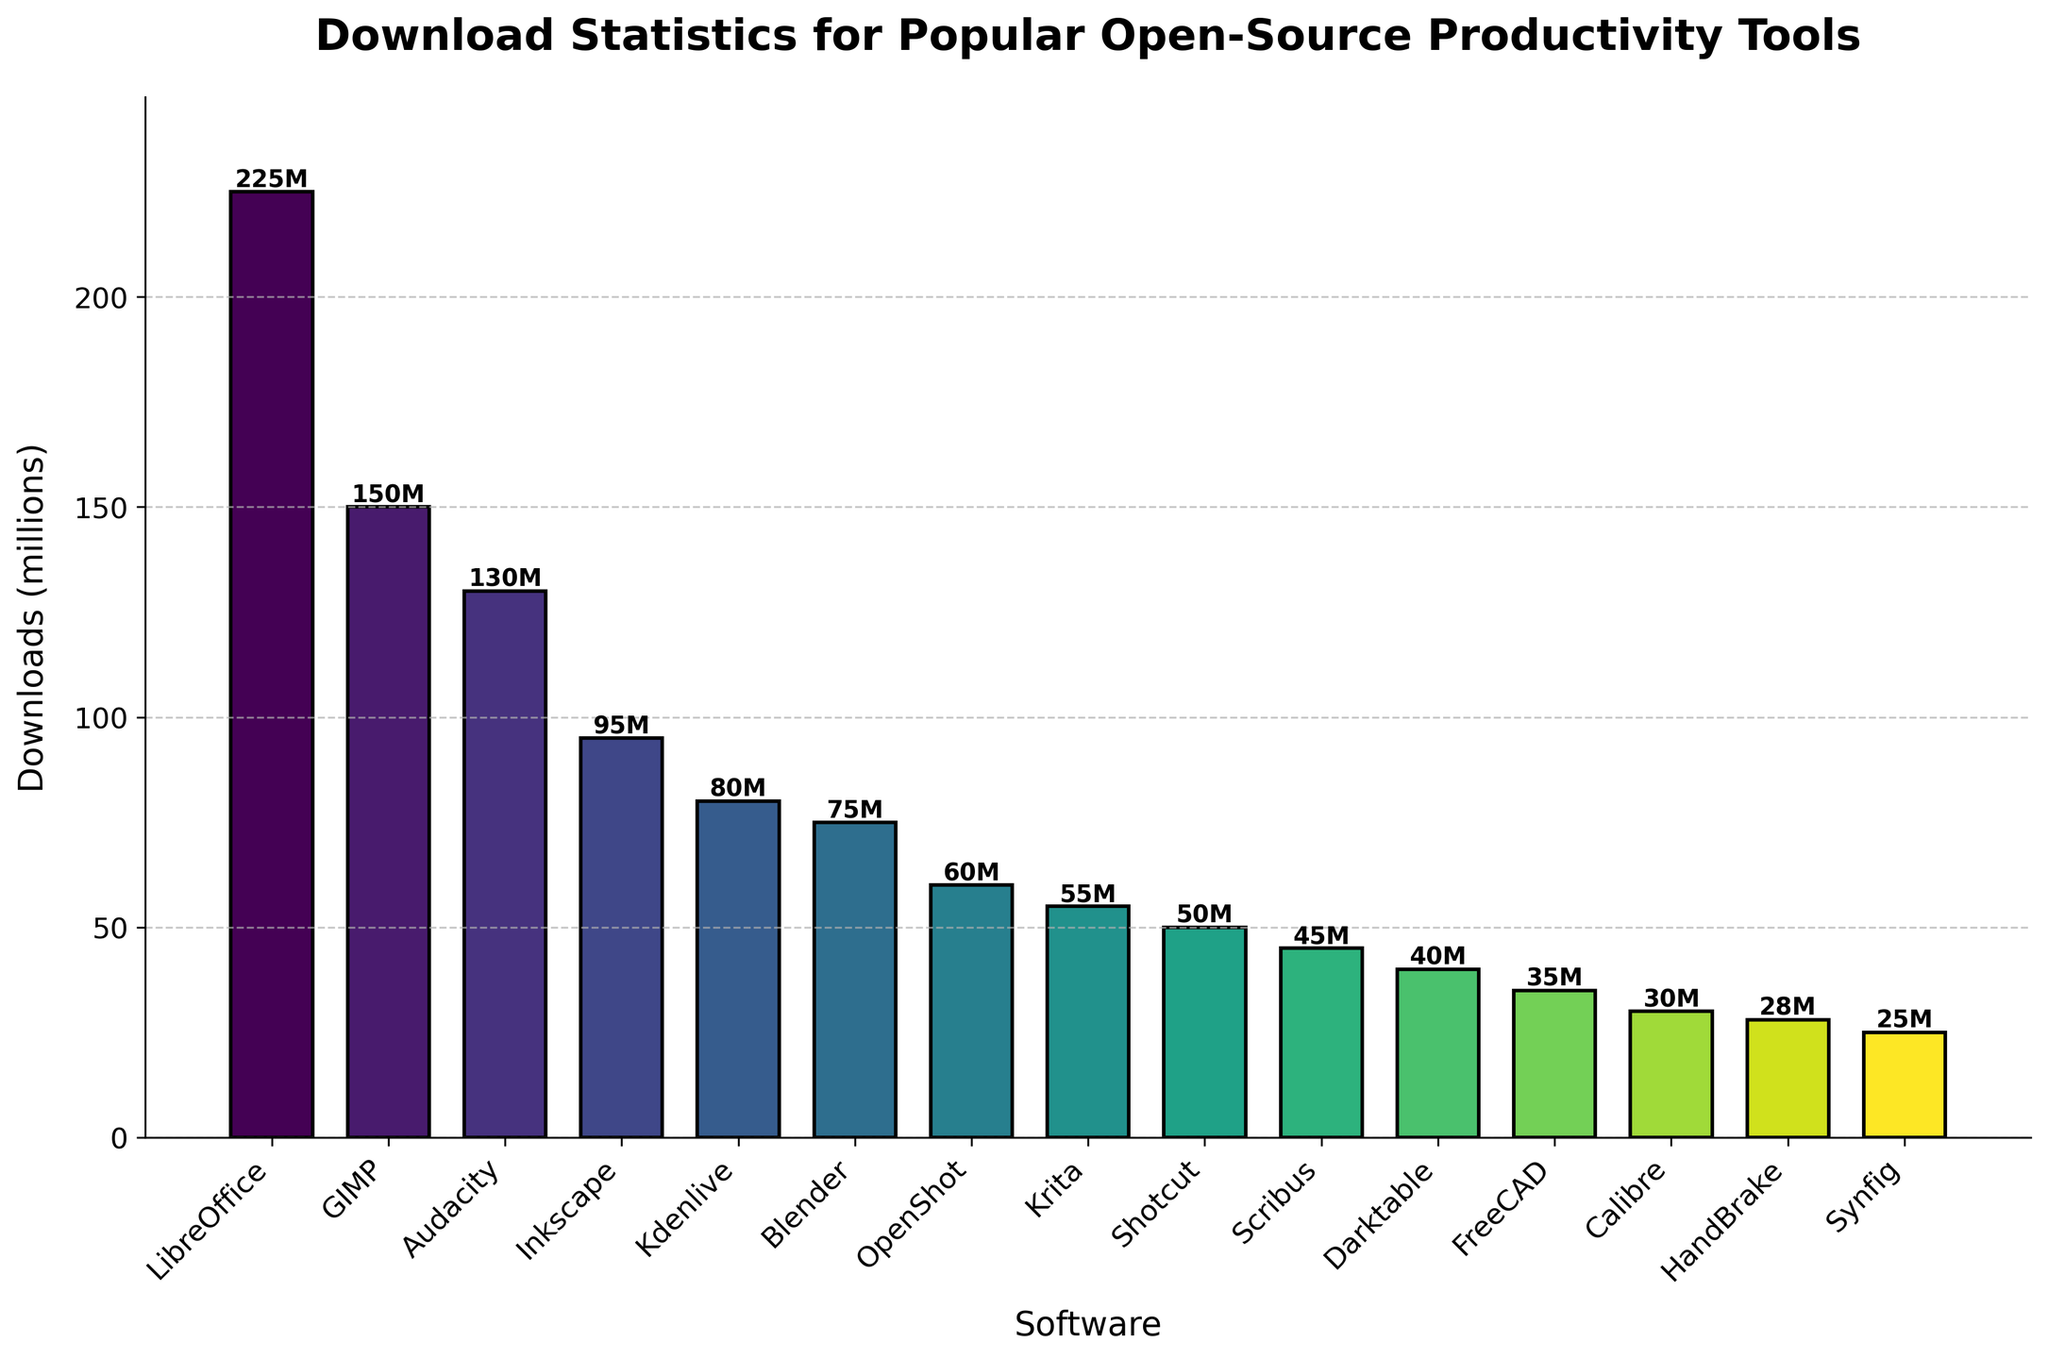Which software has the highest number of downloads? By examining the height of the bars in the chart, we can see that the bar for LibreOffice is the tallest, indicating it has the highest number of downloads
Answer: LibreOffice Which software has the lowest number of downloads? By looking at the shortest bar in the chart, we can determine that the bar for Synfig is the shortest, indicating it has the lowest number of downloads
Answer: Synfig What is the total number of downloads for GIMP, Audacity, and Inkscape combined? Add up the downloads for GIMP (150M), Audacity (130M), and Inkscape (95M): 150 + 130 + 95 = 375
Answer: 375 million Which software has fewer downloads: Kdenlive or Blender? Compare the height of the bars for Kdenlive and Blender. The bar for Blender is shorter than Kdenlive, indicating Blender has fewer downloads
Answer: Blender How many downloads does Audacity have relative to Kdenlive's downloads? Audacity has 130M downloads, and Kdenlive has 80M downloads. To find the relative amount: 130 - 80 = 50
Answer: 50 million more What is the average number of downloads for the software listed? The total sum of downloads for all software is: 225 + 150 + 130 + 95 + 80 + 75 + 60 + 55 + 50 + 45 + 40 + 35 + 30 + 28 + 25 = 1123. There are 15 software items, so the average is: 1123 / 15 = 74.87
Answer: 74.87 million Identify the software with more than 100 million downloads but less than 200 million downloads The software in this range is GIMP (150M) and Audacity (130M)
Answer: GIMP and Audacity Is the color of the bar for LibreOffice lighter or darker than the bar for Synfig? According to the viridis colormap, bars representing higher values are lighter. The bar for LibreOffice is lighter in color than the bar for Synfig
Answer: Lighter Calculate the difference in downloads between Inkscape and Shotcut Inkscape has 95M downloads, and Shotcut has 50M downloads. The difference is: 95 - 50 = 45
Answer: 45 million How many unique software have downloads more than 50 million but less than 100 million? The software in this download range are Inkscape (95M), Kdenlive (80M), Blender (75M), OpenShot (60M), and Krita (55M). There are 5 such software
Answer: 5 